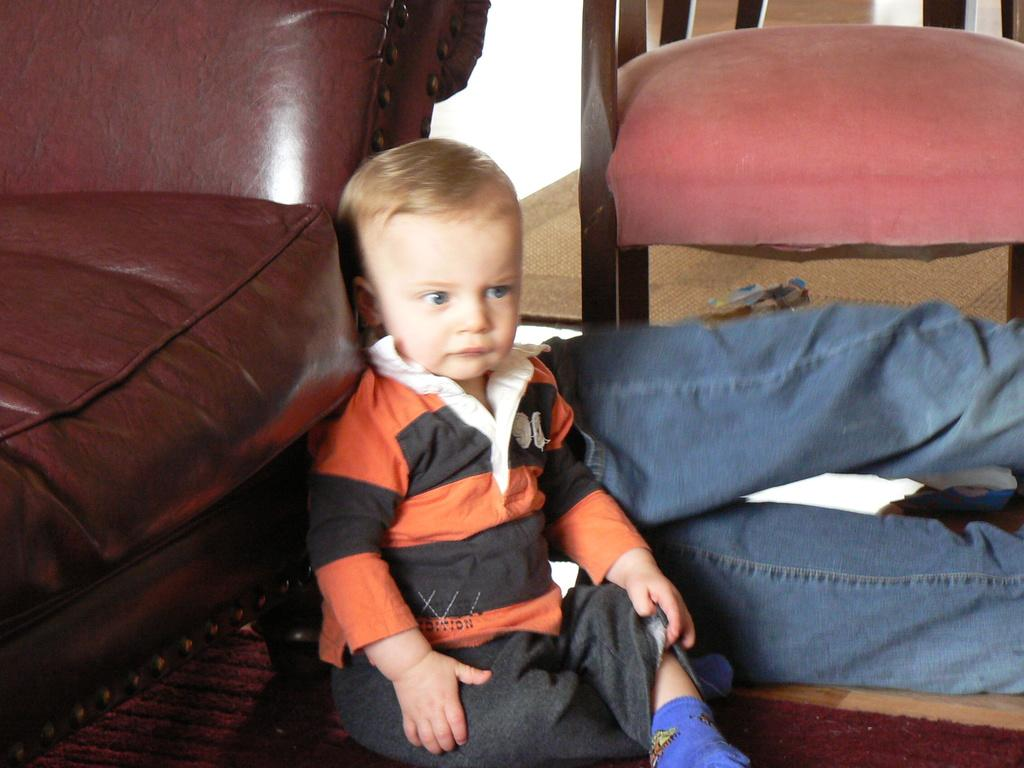What is the main subject of the image? There is a little guy in the image. What is the little guy wearing? The little guy is wearing a black and orange shirt. Where is the little guy sitting? The little guy is sitting on the floor. What piece of furniture can be seen in the image? There is a red sofa in the image. What team does the little guy support, as indicated by the colors of his shirt in the image? The image does not provide any information about the little guy's shirt being related to a specific team. Is the little guy taking a bath in the image? There is no indication of a bath or any water-related activity in the image. 